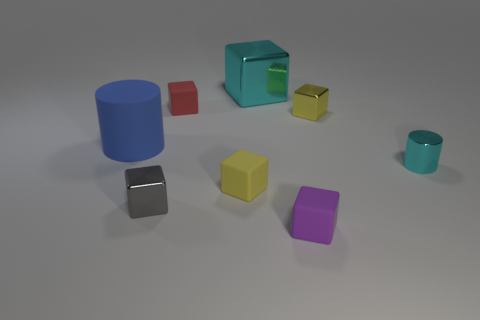Subtract all tiny yellow cubes. How many cubes are left? 4 Subtract all red cubes. How many cubes are left? 5 Subtract all blue blocks. Subtract all brown cylinders. How many blocks are left? 6 Add 2 big blue shiny blocks. How many objects exist? 10 Subtract all cylinders. How many objects are left? 6 Add 4 purple rubber blocks. How many purple rubber blocks exist? 5 Subtract 1 purple cubes. How many objects are left? 7 Subtract all tiny blocks. Subtract all cyan things. How many objects are left? 1 Add 5 tiny metal objects. How many tiny metal objects are left? 8 